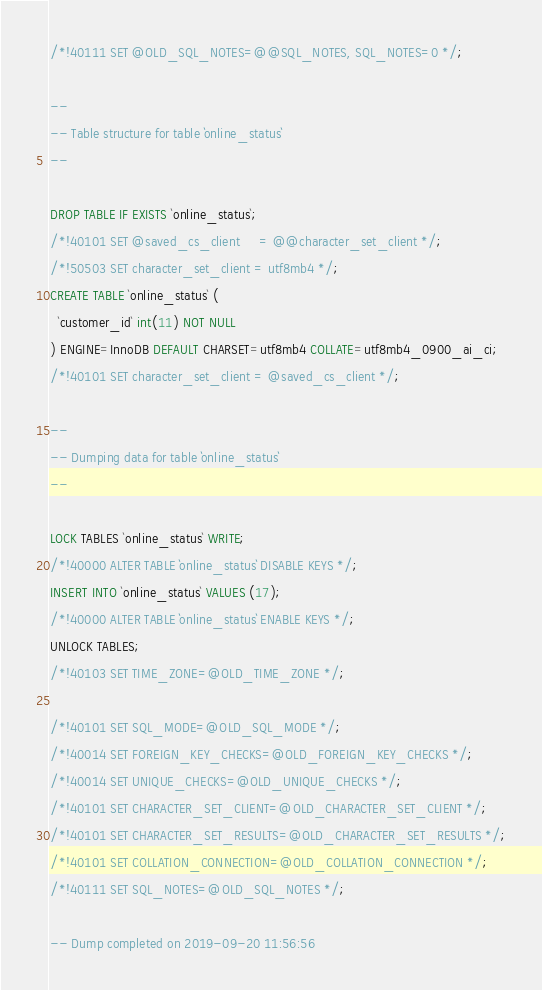<code> <loc_0><loc_0><loc_500><loc_500><_SQL_>/*!40111 SET @OLD_SQL_NOTES=@@SQL_NOTES, SQL_NOTES=0 */;

--
-- Table structure for table `online_status`
--

DROP TABLE IF EXISTS `online_status`;
/*!40101 SET @saved_cs_client     = @@character_set_client */;
/*!50503 SET character_set_client = utf8mb4 */;
CREATE TABLE `online_status` (
  `customer_id` int(11) NOT NULL
) ENGINE=InnoDB DEFAULT CHARSET=utf8mb4 COLLATE=utf8mb4_0900_ai_ci;
/*!40101 SET character_set_client = @saved_cs_client */;

--
-- Dumping data for table `online_status`
--

LOCK TABLES `online_status` WRITE;
/*!40000 ALTER TABLE `online_status` DISABLE KEYS */;
INSERT INTO `online_status` VALUES (17);
/*!40000 ALTER TABLE `online_status` ENABLE KEYS */;
UNLOCK TABLES;
/*!40103 SET TIME_ZONE=@OLD_TIME_ZONE */;

/*!40101 SET SQL_MODE=@OLD_SQL_MODE */;
/*!40014 SET FOREIGN_KEY_CHECKS=@OLD_FOREIGN_KEY_CHECKS */;
/*!40014 SET UNIQUE_CHECKS=@OLD_UNIQUE_CHECKS */;
/*!40101 SET CHARACTER_SET_CLIENT=@OLD_CHARACTER_SET_CLIENT */;
/*!40101 SET CHARACTER_SET_RESULTS=@OLD_CHARACTER_SET_RESULTS */;
/*!40101 SET COLLATION_CONNECTION=@OLD_COLLATION_CONNECTION */;
/*!40111 SET SQL_NOTES=@OLD_SQL_NOTES */;

-- Dump completed on 2019-09-20 11:56:56
</code> 